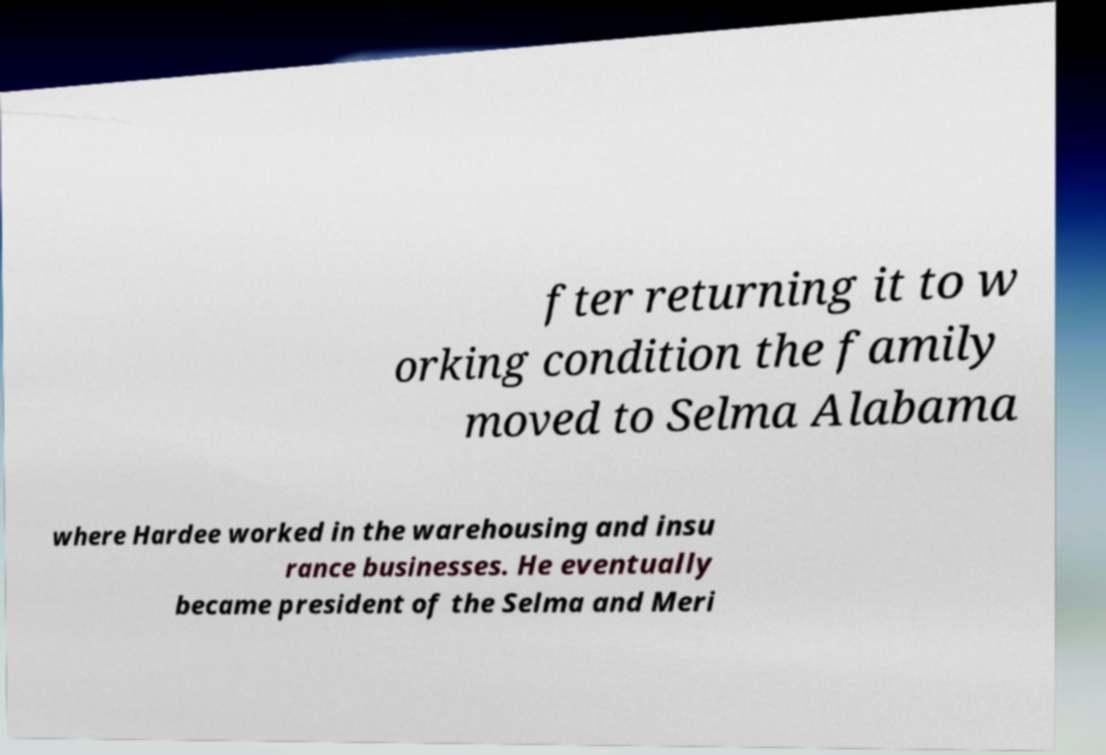Could you assist in decoding the text presented in this image and type it out clearly? fter returning it to w orking condition the family moved to Selma Alabama where Hardee worked in the warehousing and insu rance businesses. He eventually became president of the Selma and Meri 